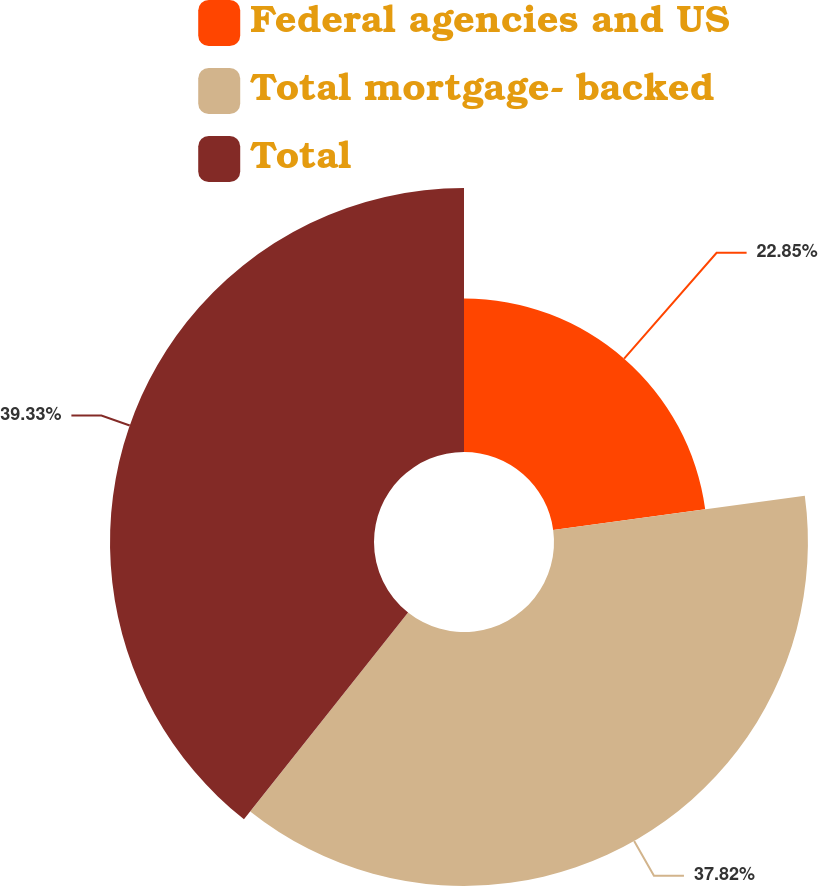Convert chart to OTSL. <chart><loc_0><loc_0><loc_500><loc_500><pie_chart><fcel>Federal agencies and US<fcel>Total mortgage- backed<fcel>Total<nl><fcel>22.85%<fcel>37.82%<fcel>39.32%<nl></chart> 